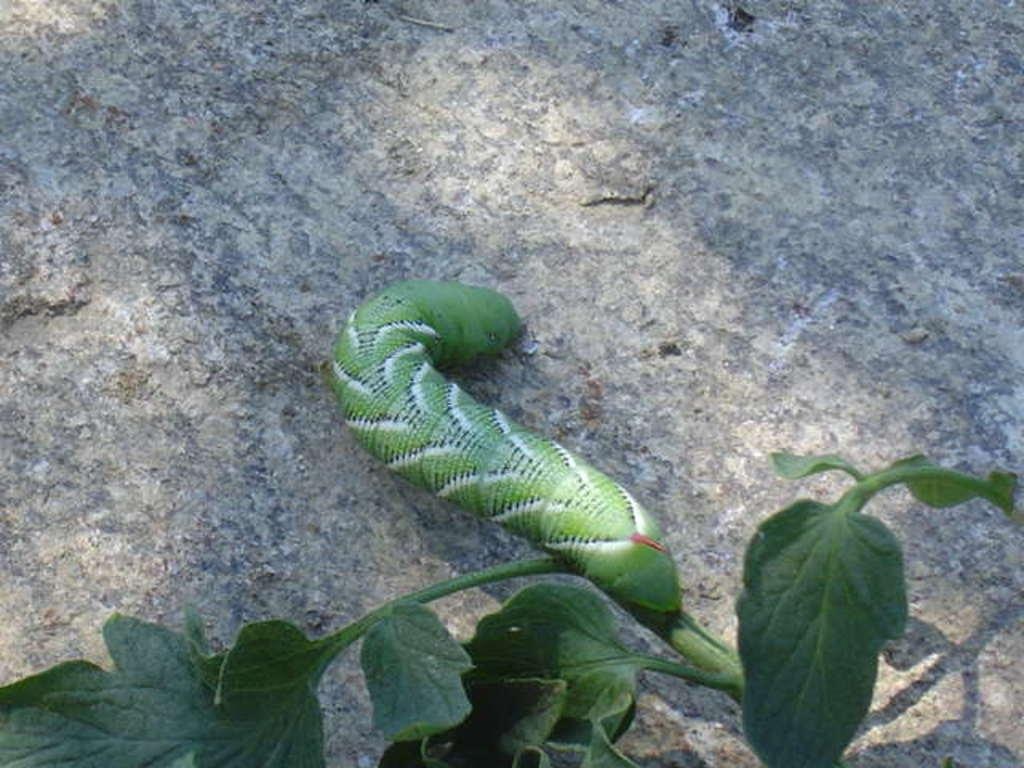What is the main subject of the image? The main subject of the image is a worm on a stone. What can be seen at the bottom of the image? There are green leaves at the bottom of the image. What type of food is the worm eating in the image? There is no indication in the image that the worm is eating any food, so it cannot be determined from the picture. 